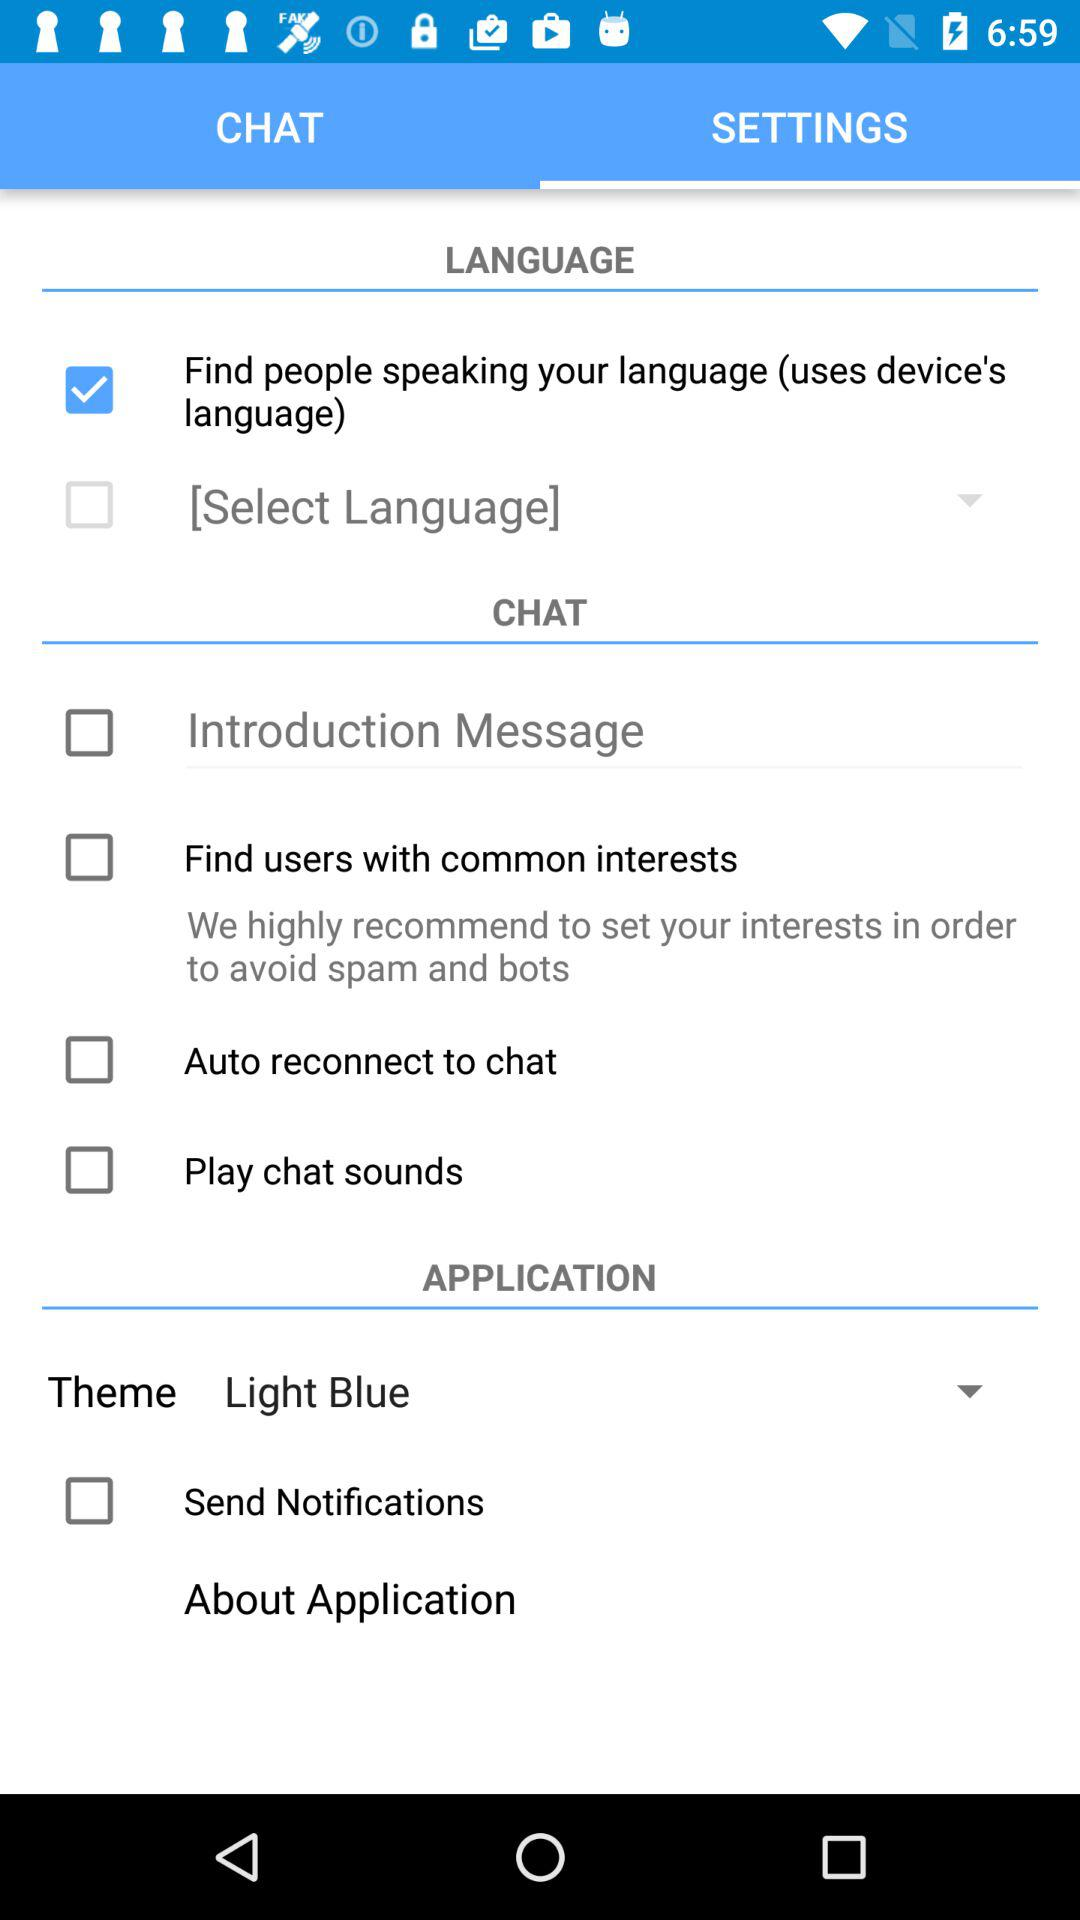What is the status of "Find people speaking your language"? The status is "on". 